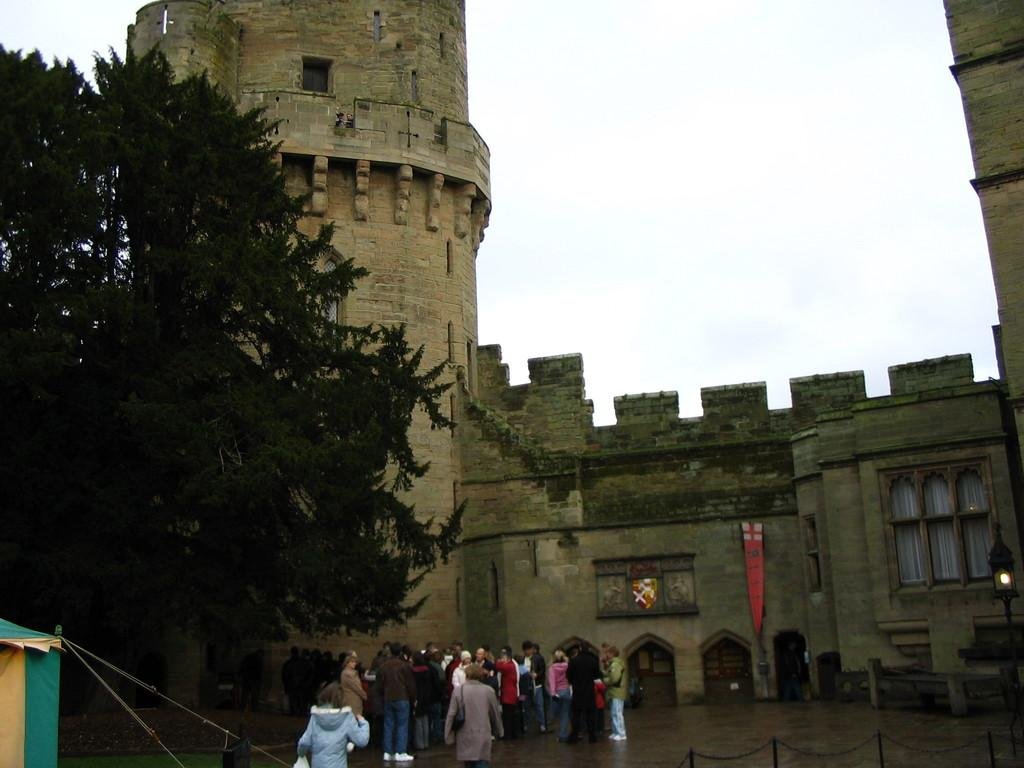How many people are in the image? There are many people in the image. What is located on the left side of the image? There is a tree on the left side of the image. What structure can be seen with ropes in the image? There is a tent with ropes in the image. What type of building is visible in the background of the image? There is a fort with windows in the background of the image. What is visible in the sky in the image? The sky is visible in the background of the image. What type of berry is being used to flavor the geese in the image? There are no berries, flavors, or geese present in the image. 